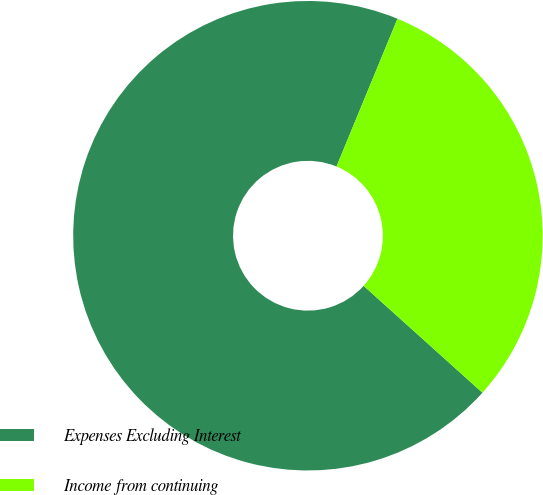Convert chart to OTSL. <chart><loc_0><loc_0><loc_500><loc_500><pie_chart><fcel>Expenses Excluding Interest<fcel>Income from continuing<nl><fcel>69.57%<fcel>30.43%<nl></chart> 